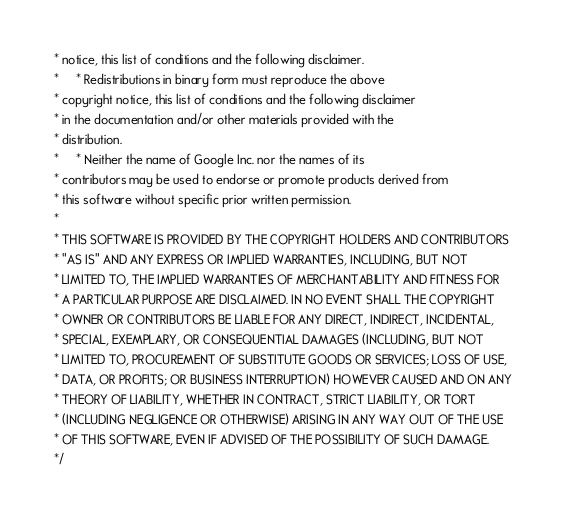<code> <loc_0><loc_0><loc_500><loc_500><_C_> * notice, this list of conditions and the following disclaimer.
 *     * Redistributions in binary form must reproduce the above
 * copyright notice, this list of conditions and the following disclaimer
 * in the documentation and/or other materials provided with the
 * distribution.
 *     * Neither the name of Google Inc. nor the names of its
 * contributors may be used to endorse or promote products derived from
 * this software without specific prior written permission.
 *
 * THIS SOFTWARE IS PROVIDED BY THE COPYRIGHT HOLDERS AND CONTRIBUTORS
 * "AS IS" AND ANY EXPRESS OR IMPLIED WARRANTIES, INCLUDING, BUT NOT
 * LIMITED TO, THE IMPLIED WARRANTIES OF MERCHANTABILITY AND FITNESS FOR
 * A PARTICULAR PURPOSE ARE DISCLAIMED. IN NO EVENT SHALL THE COPYRIGHT
 * OWNER OR CONTRIBUTORS BE LIABLE FOR ANY DIRECT, INDIRECT, INCIDENTAL,
 * SPECIAL, EXEMPLARY, OR CONSEQUENTIAL DAMAGES (INCLUDING, BUT NOT
 * LIMITED TO, PROCUREMENT OF SUBSTITUTE GOODS OR SERVICES; LOSS OF USE,
 * DATA, OR PROFITS; OR BUSINESS INTERRUPTION) HOWEVER CAUSED AND ON ANY
 * THEORY OF LIABILITY, WHETHER IN CONTRACT, STRICT LIABILITY, OR TORT
 * (INCLUDING NEGLIGENCE OR OTHERWISE) ARISING IN ANY WAY OUT OF THE USE
 * OF THIS SOFTWARE, EVEN IF ADVISED OF THE POSSIBILITY OF SUCH DAMAGE.
 */
</code> 